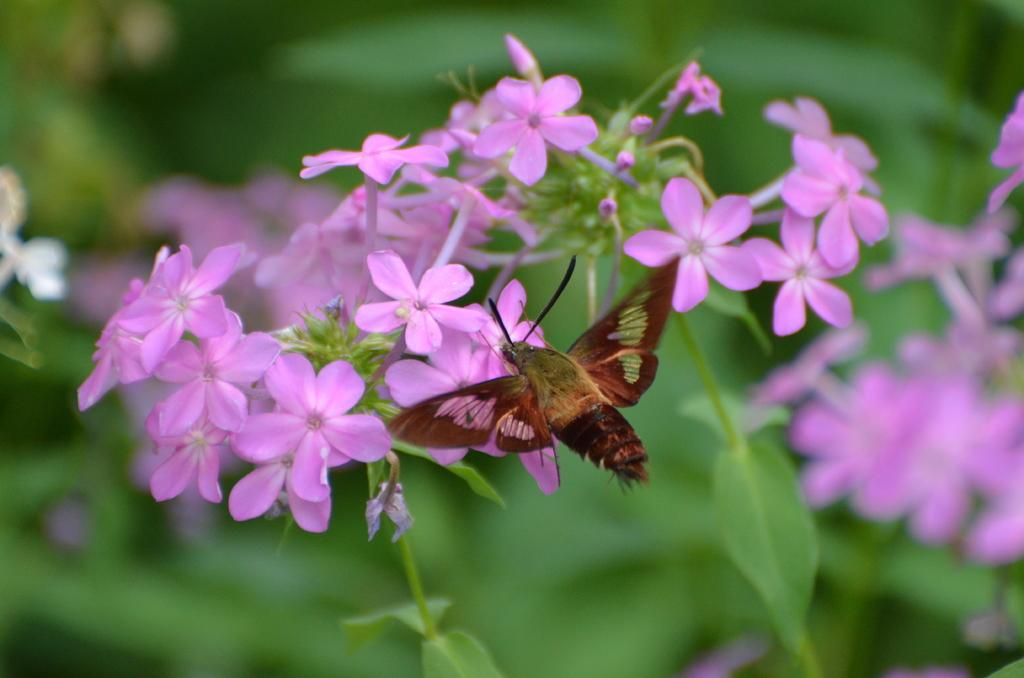What is the main subject of the image? There are many flowers in the center of the image. Are there any living creatures in the image? Yes, there is an insect in the image. What can be seen in the background of the image? There are leaves in the background of the image. What type of pain can be seen on the insect's face in the image? There is no indication of pain on the insect's face in the image, and insects do not have facial expressions like humans. 